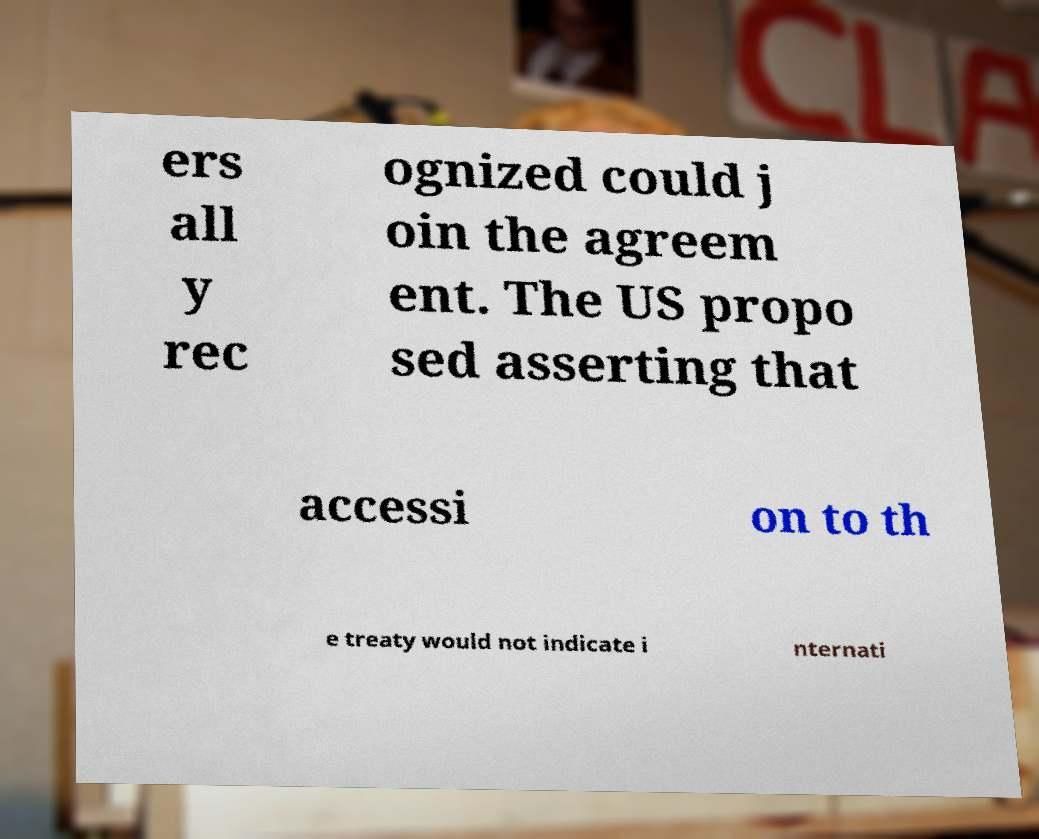Could you extract and type out the text from this image? ers all y rec ognized could j oin the agreem ent. The US propo sed asserting that accessi on to th e treaty would not indicate i nternati 